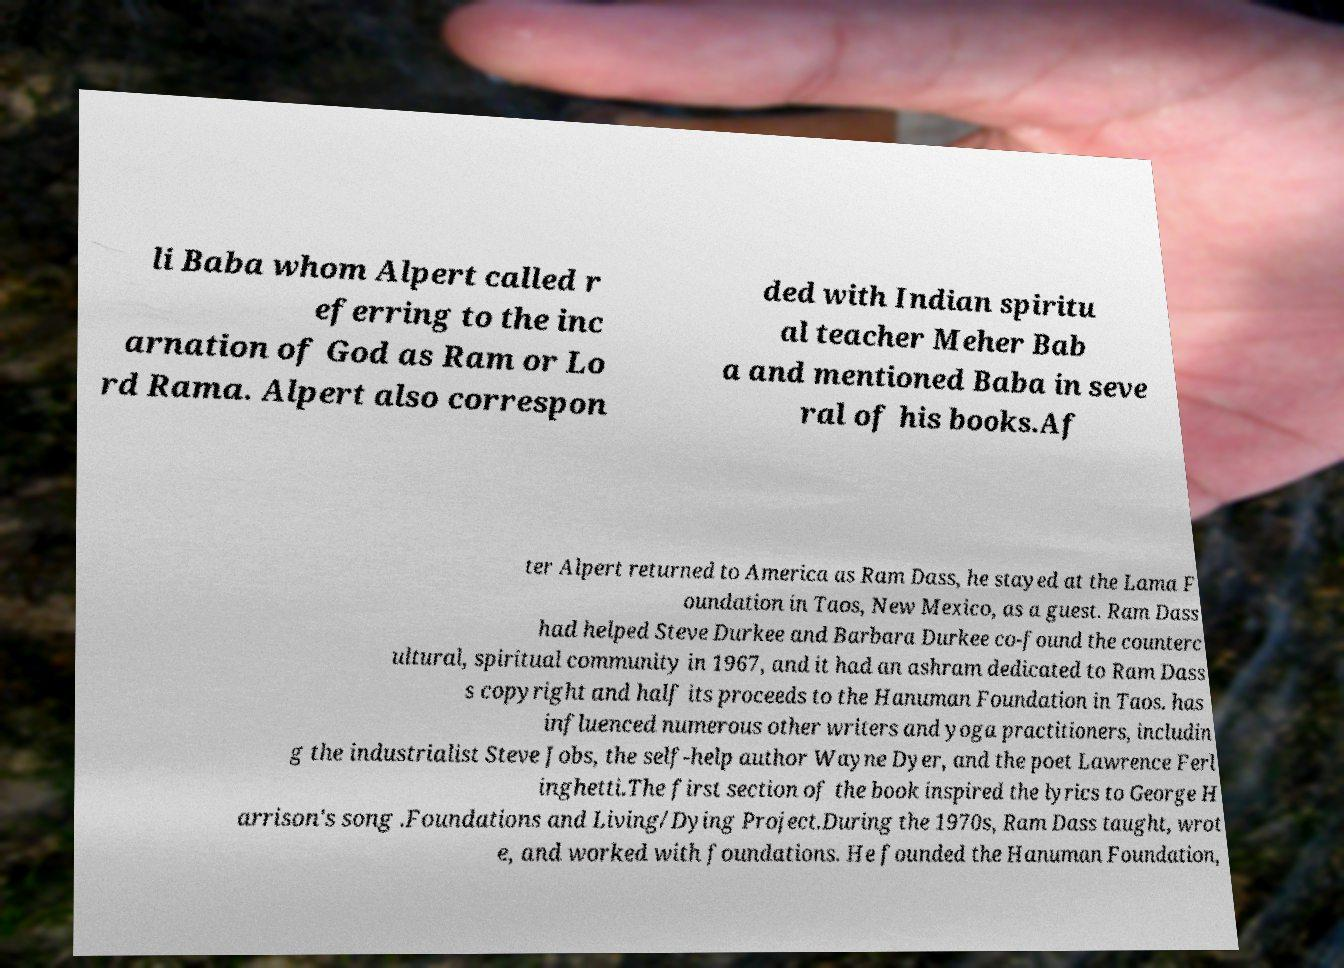For documentation purposes, I need the text within this image transcribed. Could you provide that? li Baba whom Alpert called r eferring to the inc arnation of God as Ram or Lo rd Rama. Alpert also correspon ded with Indian spiritu al teacher Meher Bab a and mentioned Baba in seve ral of his books.Af ter Alpert returned to America as Ram Dass, he stayed at the Lama F oundation in Taos, New Mexico, as a guest. Ram Dass had helped Steve Durkee and Barbara Durkee co-found the counterc ultural, spiritual community in 1967, and it had an ashram dedicated to Ram Dass s copyright and half its proceeds to the Hanuman Foundation in Taos. has influenced numerous other writers and yoga practitioners, includin g the industrialist Steve Jobs, the self-help author Wayne Dyer, and the poet Lawrence Ferl inghetti.The first section of the book inspired the lyrics to George H arrison's song .Foundations and Living/Dying Project.During the 1970s, Ram Dass taught, wrot e, and worked with foundations. He founded the Hanuman Foundation, 